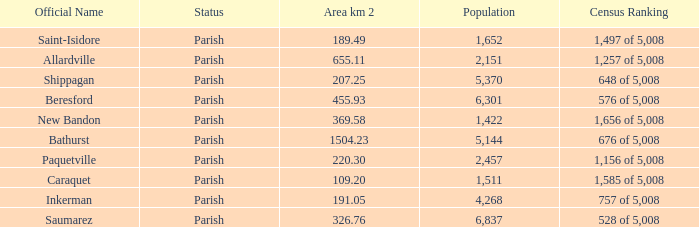What is the Population of the New Bandon Parish with an Area km 2 larger than 326.76? 1422.0. 